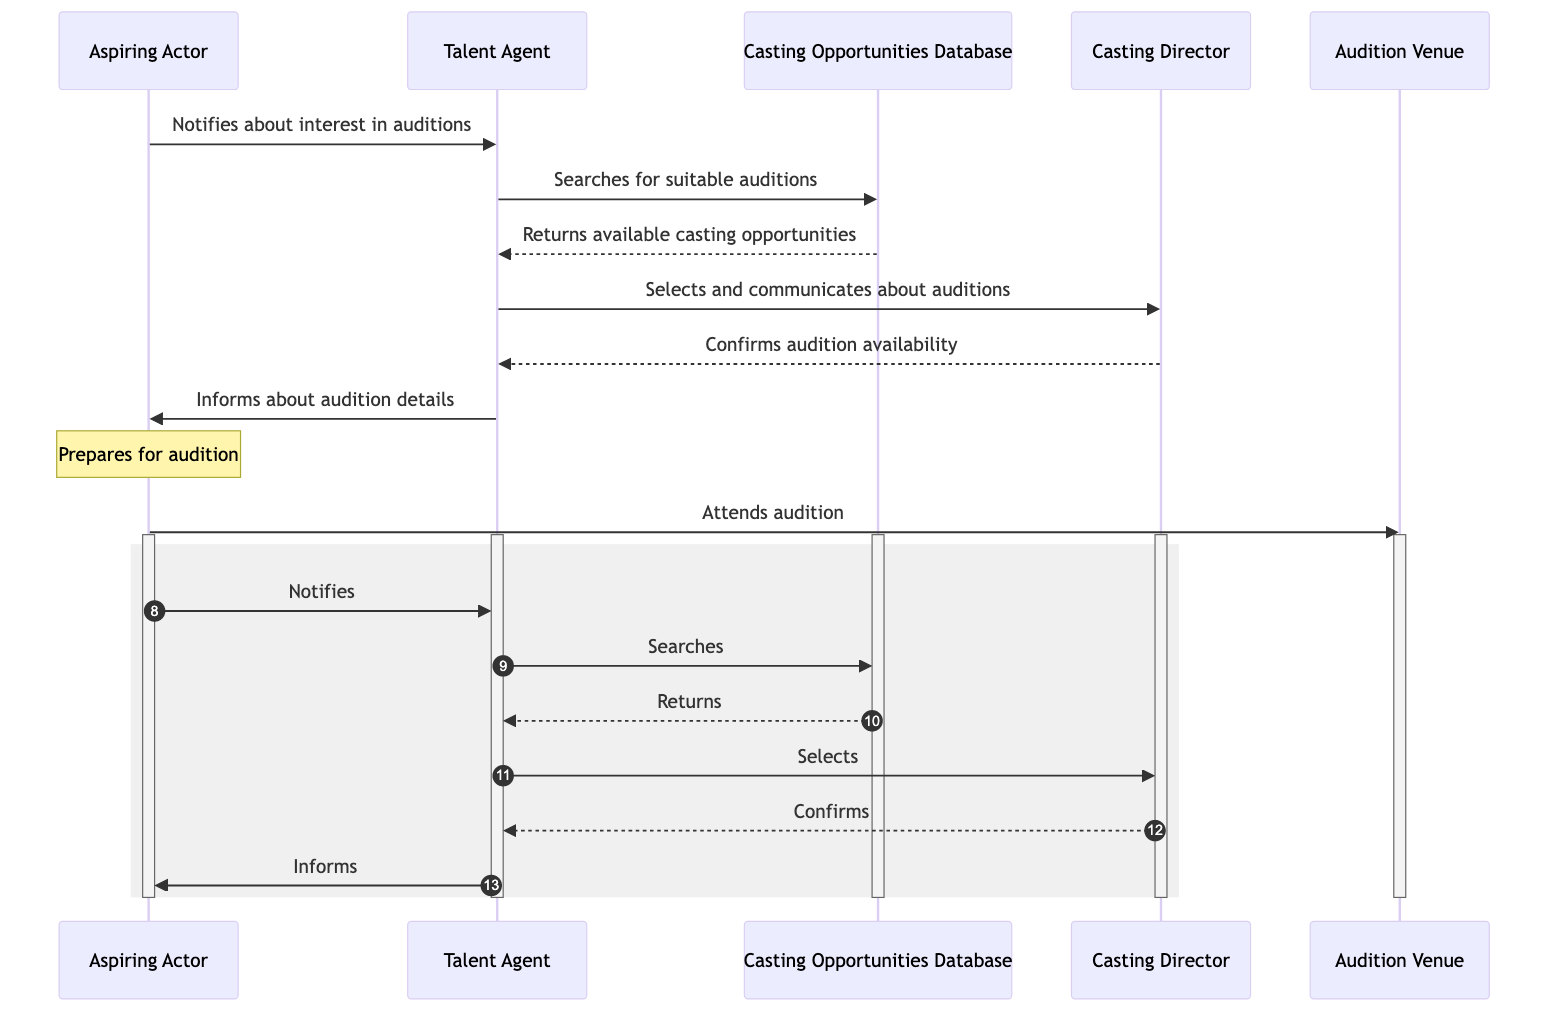What actor initiates the booking process? The Aspiring Actor is the first actor in the diagram, who notifies their Talent Agent about their interest in auditions. This is the starting point of the entire flow depicted in the sequence diagram.
Answer: Aspiring Actor How many participants are involved in the sequence diagram? The diagram includes five participants: Aspiring Actor, Talent Agent, Casting Opportunities Database, Casting Director, and Audition Venue. By counting the unique participant names, we find there are five distinct entities.
Answer: Five What action does the Talent Agent take after receiving information from the Aspiring Actor? After the Aspiring Actor notifies the Talent Agent, the next action taken by the Talent Agent is to search the Casting Opportunities Database for suitable auditions. This shows the direct consequence of the actor's notification.
Answer: Searches What does the Casting Director do after the Talent Agent selects auditions? The Casting Director confirms the availability of the audition after being communicated with by the Talent Agent. This indicates that the Casting Director plays a crucial role in acknowledging or validating the auditions.
Answer: Confirms What is the last action performed by the Aspiring Actor in the sequence? The Aspiring Actor attends the audition at the designated venue as the final step of the whole booking process. This is the concluding action representing the actor's participation in the audition.
Answer: Attends Which participant receives information about the audition details? The Talent Agent informs the Aspiring Actor about the audition details. This shows the flow of information from the agent back to the actor after coordinating the audition.
Answer: Aspiring Actor What action occurs after the Casting Opportunities Database returns results? After the Casting Opportunities Database returns the available casting opportunities to the Talent Agent, the next action is for the Talent Agent to select suitable auditions and communicate them to the Casting Director. This forms a logical sequence of events following the database response.
Answer: Selects What type of diagram is represented here? The diagram is a sequence diagram, which illustrates the interaction and order of processes between different entities involved in booking an audition through an agent. Sequence diagrams specifically emphasize the timing and order of messages exchanged between actors.
Answer: Sequence diagram How does the Aspiring Actor prepare for the audition? The Aspiring Actor prepares for the audition using the details that were provided by the Talent Agent. It emphasizes how the actor utilizes the information received to get ready for their performance.
Answer: Prepares 